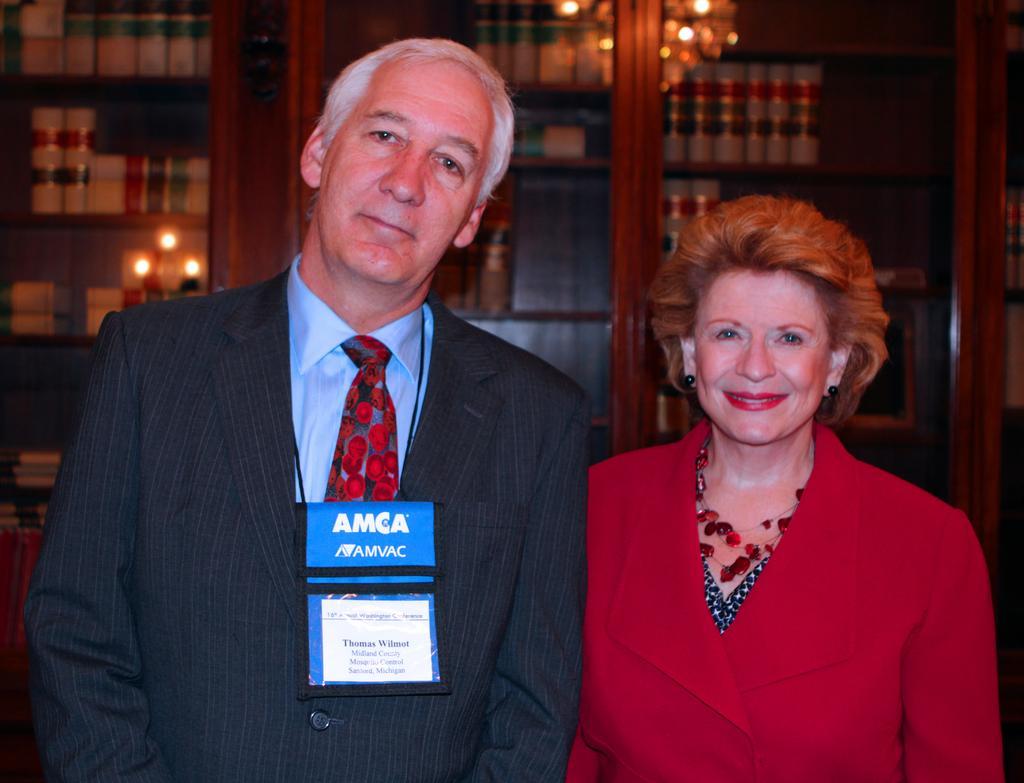In one or two sentences, can you explain what this image depicts? In this image I can see a person wearing blue shirt, red tie and blazer is standing and a woman wearing red dress is standing. In the background I can see a bookshelf with few books in it. I can see the reflection of few lights on the glass door of the shelves. 